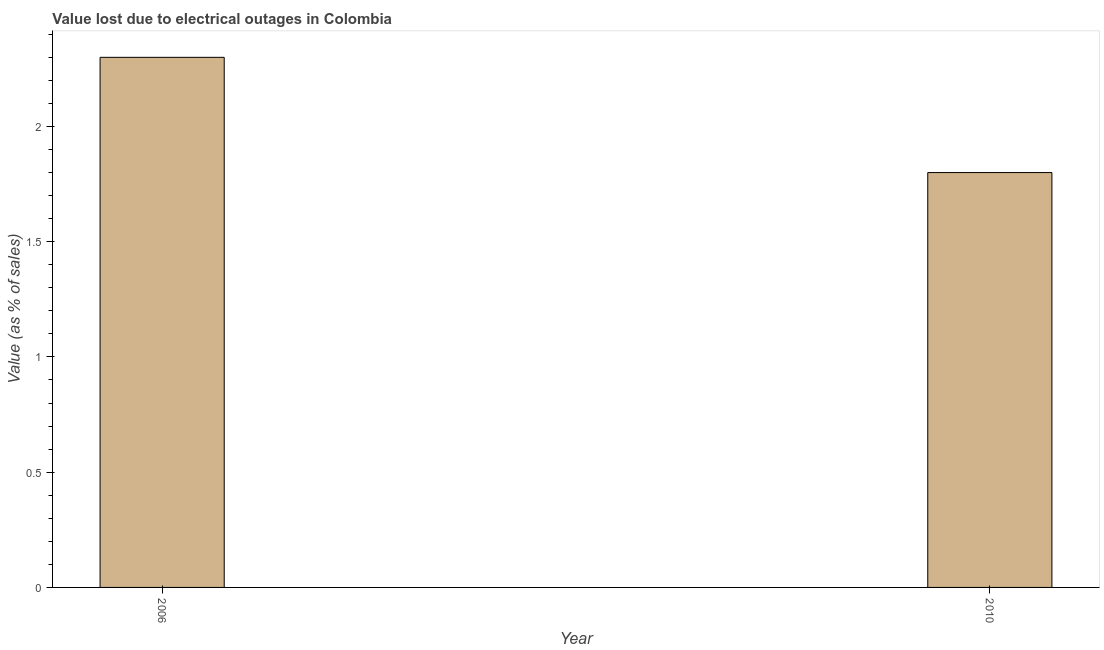Does the graph contain any zero values?
Make the answer very short. No. What is the title of the graph?
Offer a terse response. Value lost due to electrical outages in Colombia. What is the label or title of the Y-axis?
Provide a succinct answer. Value (as % of sales). Across all years, what is the maximum value lost due to electrical outages?
Ensure brevity in your answer.  2.3. In which year was the value lost due to electrical outages maximum?
Your answer should be compact. 2006. In which year was the value lost due to electrical outages minimum?
Offer a very short reply. 2010. What is the difference between the value lost due to electrical outages in 2006 and 2010?
Your response must be concise. 0.5. What is the average value lost due to electrical outages per year?
Your response must be concise. 2.05. What is the median value lost due to electrical outages?
Your answer should be compact. 2.05. Do a majority of the years between 2006 and 2010 (inclusive) have value lost due to electrical outages greater than 2 %?
Ensure brevity in your answer.  No. What is the ratio of the value lost due to electrical outages in 2006 to that in 2010?
Ensure brevity in your answer.  1.28. In how many years, is the value lost due to electrical outages greater than the average value lost due to electrical outages taken over all years?
Make the answer very short. 1. How many bars are there?
Offer a terse response. 2. Are the values on the major ticks of Y-axis written in scientific E-notation?
Provide a succinct answer. No. What is the Value (as % of sales) in 2010?
Your response must be concise. 1.8. What is the difference between the Value (as % of sales) in 2006 and 2010?
Your answer should be very brief. 0.5. What is the ratio of the Value (as % of sales) in 2006 to that in 2010?
Your answer should be compact. 1.28. 